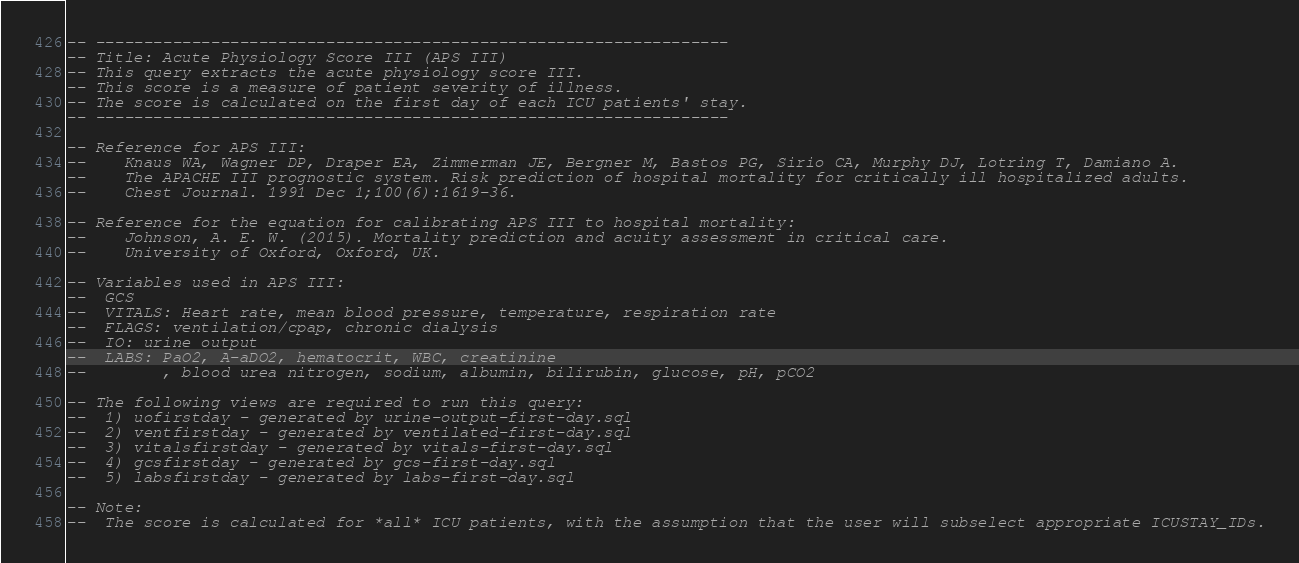<code> <loc_0><loc_0><loc_500><loc_500><_SQL_>-- ------------------------------------------------------------------
-- Title: Acute Physiology Score III (APS III)
-- This query extracts the acute physiology score III.
-- This score is a measure of patient severity of illness.
-- The score is calculated on the first day of each ICU patients' stay.
-- ------------------------------------------------------------------

-- Reference for APS III:
--    Knaus WA, Wagner DP, Draper EA, Zimmerman JE, Bergner M, Bastos PG, Sirio CA, Murphy DJ, Lotring T, Damiano A.
--    The APACHE III prognostic system. Risk prediction of hospital mortality for critically ill hospitalized adults.
--    Chest Journal. 1991 Dec 1;100(6):1619-36.

-- Reference for the equation for calibrating APS III to hospital mortality:
--    Johnson, A. E. W. (2015). Mortality prediction and acuity assessment in critical care.
--    University of Oxford, Oxford, UK.

-- Variables used in APS III:
--  GCS
--  VITALS: Heart rate, mean blood pressure, temperature, respiration rate
--  FLAGS: ventilation/cpap, chronic dialysis
--  IO: urine output
--  LABS: PaO2, A-aDO2, hematocrit, WBC, creatinine
--        , blood urea nitrogen, sodium, albumin, bilirubin, glucose, pH, pCO2

-- The following views are required to run this query:
--  1) uofirstday - generated by urine-output-first-day.sql
--  2) ventfirstday - generated by ventilated-first-day.sql
--  3) vitalsfirstday - generated by vitals-first-day.sql
--  4) gcsfirstday - generated by gcs-first-day.sql
--  5) labsfirstday - generated by labs-first-day.sql

-- Note:
--  The score is calculated for *all* ICU patients, with the assumption that the user will subselect appropriate ICUSTAY_IDs.</code> 